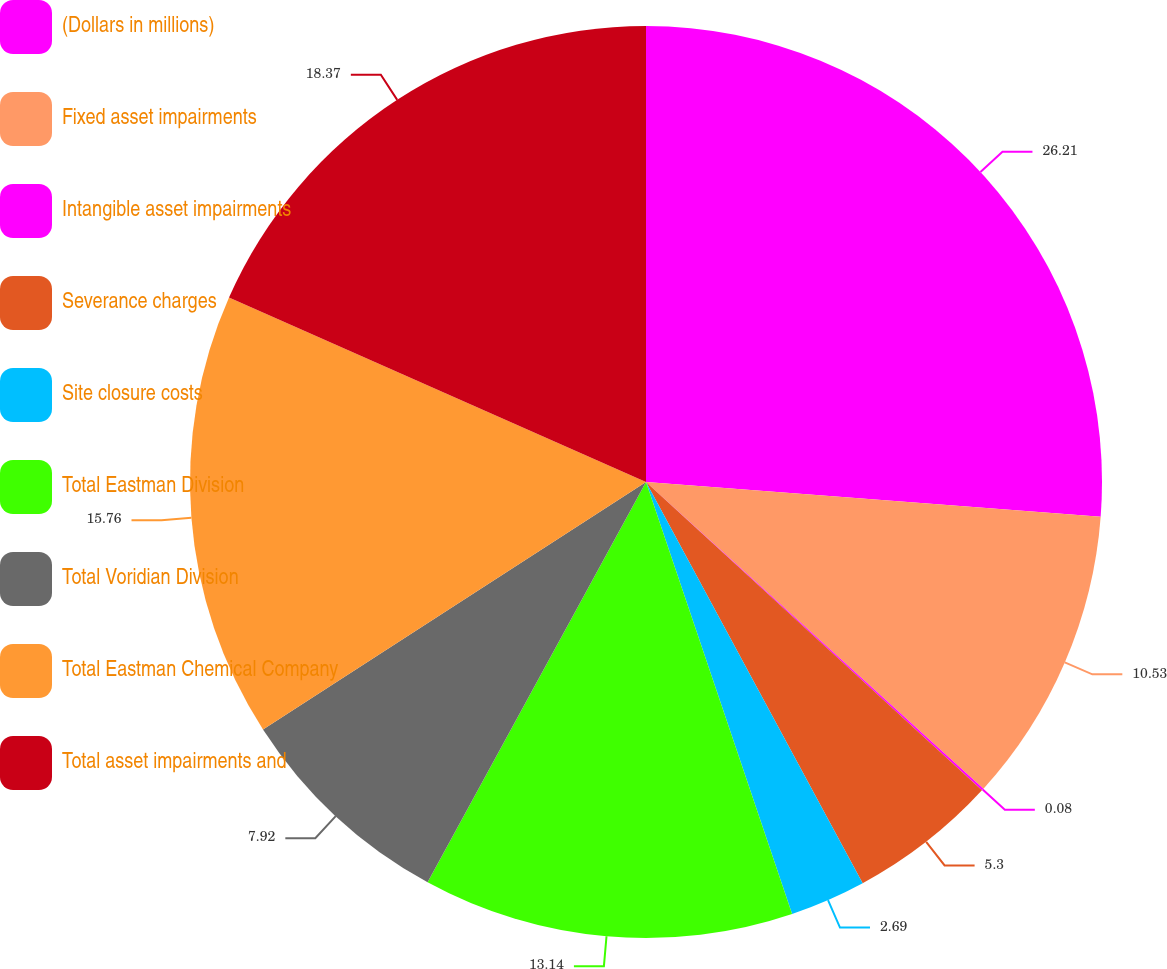Convert chart. <chart><loc_0><loc_0><loc_500><loc_500><pie_chart><fcel>(Dollars in millions)<fcel>Fixed asset impairments<fcel>Intangible asset impairments<fcel>Severance charges<fcel>Site closure costs<fcel>Total Eastman Division<fcel>Total Voridian Division<fcel>Total Eastman Chemical Company<fcel>Total asset impairments and<nl><fcel>26.21%<fcel>10.53%<fcel>0.08%<fcel>5.3%<fcel>2.69%<fcel>13.14%<fcel>7.92%<fcel>15.76%<fcel>18.37%<nl></chart> 